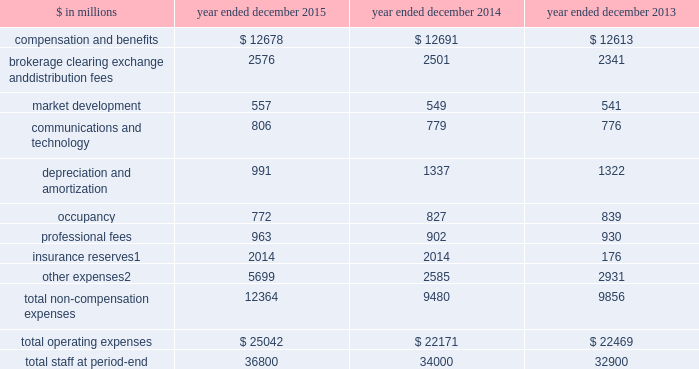The goldman sachs group , inc .
And subsidiaries management 2019s discussion and analysis operating expenses our operating expenses are primarily influenced by compensation , headcount and levels of business activity .
Compensation and benefits includes salaries , discretionary compensation , amortization of equity awards and other items such as benefits .
Discretionary compensation is significantly impacted by , among other factors , the level of net revenues , overall financial performance , prevailing labor markets , business mix , the structure of our share- based compensation programs and the external environment .
In addition , see 201cuse of estimates 201d for additional information about expenses that may arise from litigation and regulatory proceedings .
The table below presents our operating expenses and total staff ( which includes employees , consultants and temporary staff ) . .
Consists of changes in reserves related to our americas reinsurance business , including interest credited to policyholder account balances , and expenses related to property catastrophe reinsurance claims .
In april 2013 , we completed the sale of a majority stake in our americas reinsurance business and no longer consolidate this business .
Includes provisions of $ 3.37 billion recorded during 2015 for the agreement in principle with the rmbs working group .
See note 27 to the consolidated financial statements for further information about this agreement in principle .
2015 versus 2014 .
Operating expenses on the consolidated statements of earnings were $ 25.04 billion for 2015 , 13% ( 13 % ) higher than 2014 .
Compensation and benefits expenses on the consolidated statements of earnings were $ 12.68 billion for 2015 , essentially unchanged compared with 2014 .
The ratio of compensation and benefits to net revenues for 2015 was 37.5% ( 37.5 % ) compared with 36.8% ( 36.8 % ) for 2014 .
Total staff increased 8% ( 8 % ) during 2015 , primarily due to activity levels in certain businesses and continued investment in regulatory compliance .
Non-compensation expenses on the consolidated statements of earnings were $ 12.36 billion for 2015 , 30% ( 30 % ) higher than 2014 , due to significantly higher net provisions for mortgage-related litigation and regulatory matters , which are included in other expenses .
This increase was partially offset by lower depreciation and amortization expenses , primarily reflecting lower impairment charges related to consolidated investments , and a reduction in expenses related to the sale of metro in the fourth quarter of 2014 .
Net provisions for litigation and regulatory proceedings for 2015 were $ 4.01 billion compared with $ 754 million for 2014 ( both primarily comprised of net provisions for mortgage-related matters ) .
2015 included a $ 148 million charitable contribution to goldman sachs gives , our donor-advised fund .
Compensation was reduced to fund this charitable contribution to goldman sachs gives .
The firm asks its participating managing directors to make recommendations regarding potential charitable recipients for this contribution .
2014 versus 2013 .
Operating expenses on the consolidated statements of earnings were $ 22.17 billion for 2014 , essentially unchanged compared with 2013 .
Compensation and benefits expenses on the consolidated statements of earnings were $ 12.69 billion for 2014 , essentially unchanged compared with 2013 .
The ratio of compensation and benefits to net revenues for 2014 was 36.8% ( 36.8 % ) compared with 36.9% ( 36.9 % ) for 2013 .
Total staff increased 3% ( 3 % ) during 2014 .
Non-compensation expenses on the consolidated statements of earnings were $ 9.48 billion for 2014 , 4% ( 4 % ) lower than 2013 .
The decrease compared with 2013 included a decrease in other expenses , due to lower net provisions for litigation and regulatory proceedings and lower operating expenses related to consolidated investments , as well as a decline in insurance reserves , reflecting the sale of our americas reinsurance business in 2013 .
These decreases were partially offset by an increase in brokerage , clearing , exchange and distribution fees .
Net provisions for litigation and regulatory proceedings for 2014 were $ 754 million compared with $ 962 million for 2013 ( both primarily comprised of net provisions for mortgage-related matters ) .
2014 included a charitable contribution of $ 137 million to goldman sachs gives , our donor-advised fund .
Compensation was reduced to fund this charitable contribution to goldman sachs gives .
The firm asks its participating managing directors to make recommendations regarding potential charitable recipients for this contribution .
58 goldman sachs 2015 form 10-k .
What portion of the total operating expense is related to compensation and benefits in 2015? 
Computations: (12678 / 25042)
Answer: 0.50627. 